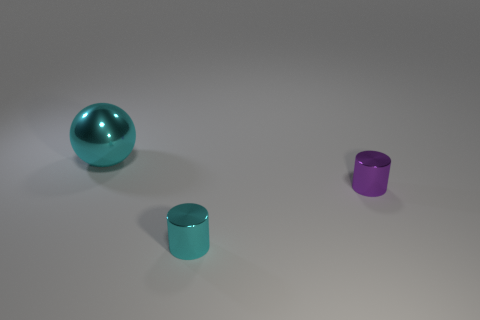Add 3 large red matte spheres. How many objects exist? 6 Subtract all balls. How many objects are left? 2 Subtract 0 brown cylinders. How many objects are left? 3 Subtract all purple cylinders. Subtract all large yellow metal cylinders. How many objects are left? 2 Add 2 tiny shiny things. How many tiny shiny things are left? 4 Add 1 big gray spheres. How many big gray spheres exist? 1 